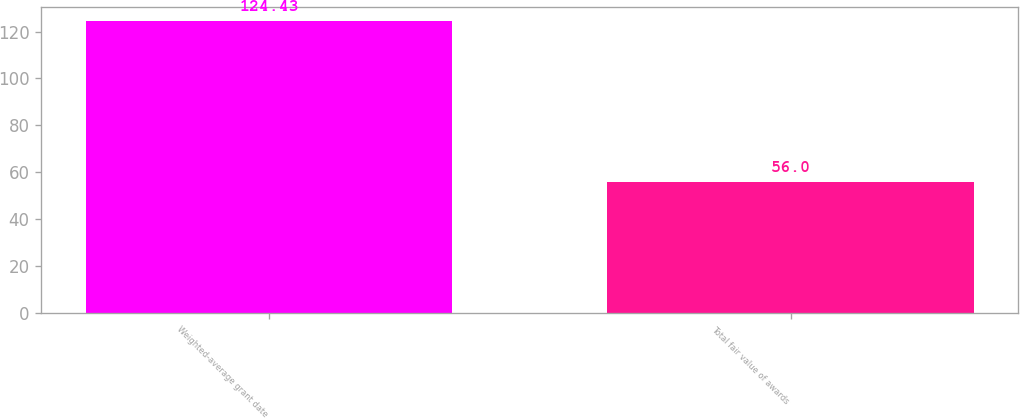Convert chart. <chart><loc_0><loc_0><loc_500><loc_500><bar_chart><fcel>Weighted-average grant date<fcel>Total fair value of awards<nl><fcel>124.43<fcel>56<nl></chart> 